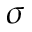Convert formula to latex. <formula><loc_0><loc_0><loc_500><loc_500>\sigma</formula> 